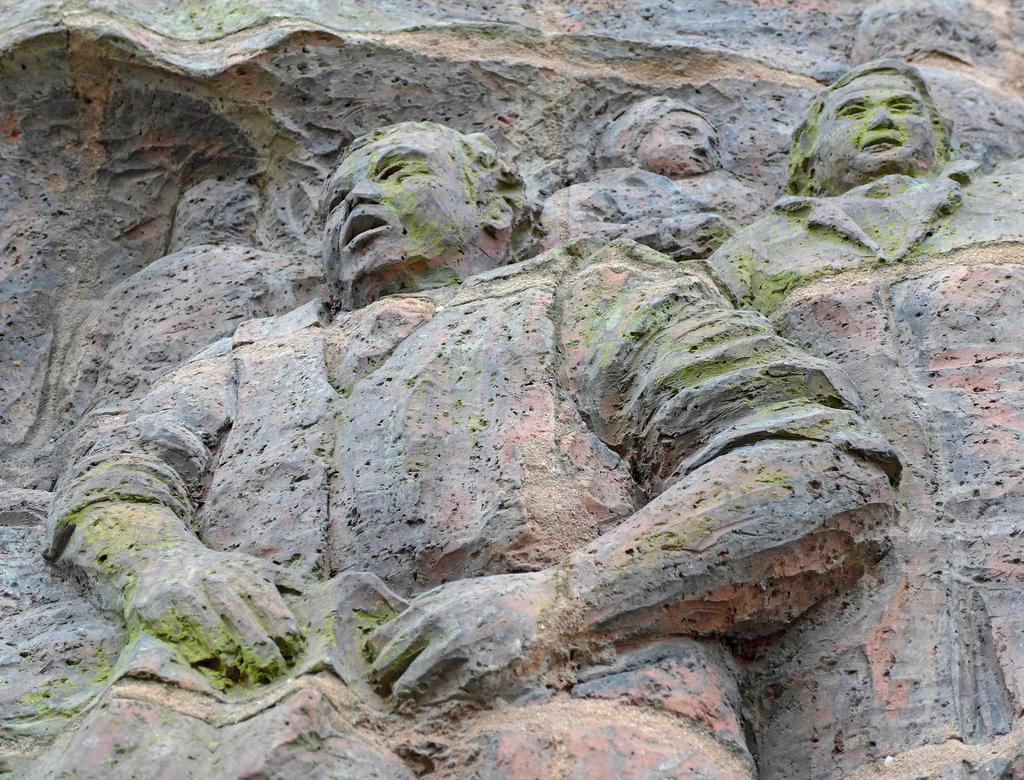What type of objects are featured in the image? There are stone sculptures in the image. What type of news can be heard from the bell in the image? There is no bell present in the image, and therefore no news can be heard from it. 